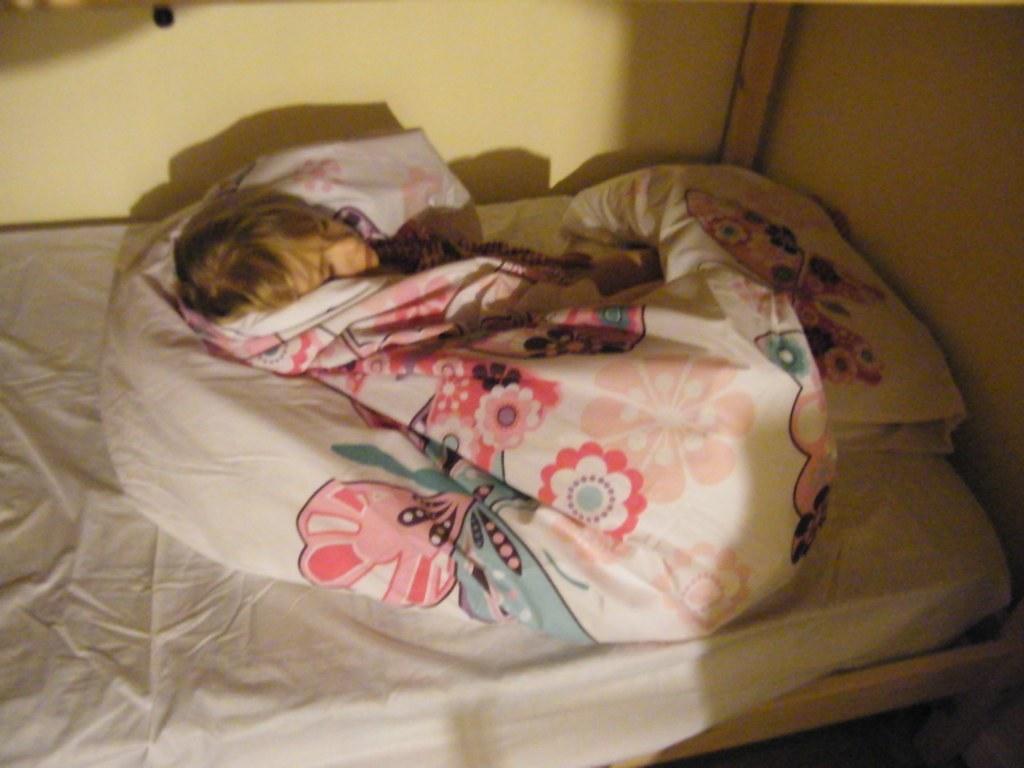In one or two sentences, can you explain what this image depicts? This picture is of inside. In the center we can see a person covered in a blanket and lying on the bed. On the right there is a pillow placed on the top of the bed. In the background we can see a wall. 